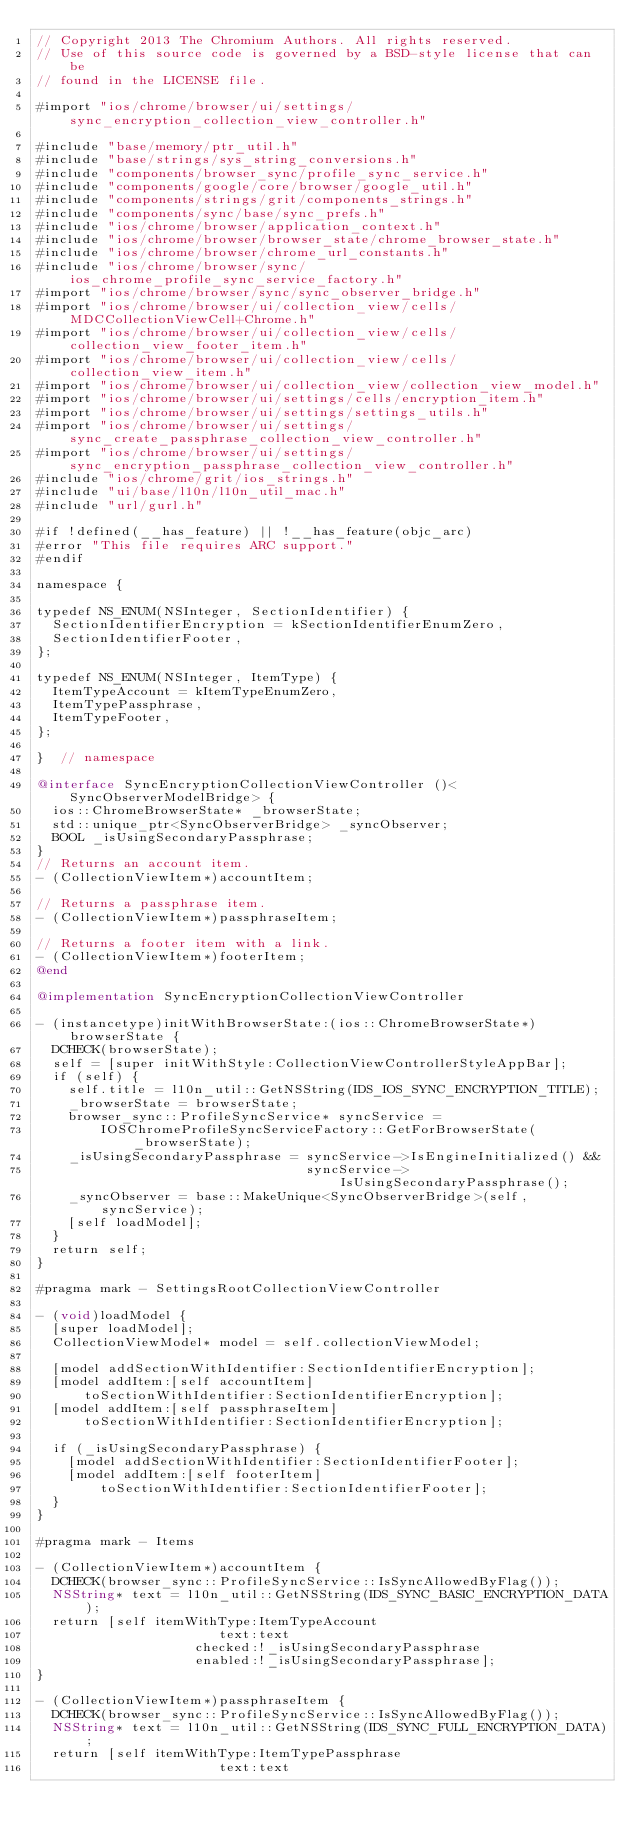Convert code to text. <code><loc_0><loc_0><loc_500><loc_500><_ObjectiveC_>// Copyright 2013 The Chromium Authors. All rights reserved.
// Use of this source code is governed by a BSD-style license that can be
// found in the LICENSE file.

#import "ios/chrome/browser/ui/settings/sync_encryption_collection_view_controller.h"

#include "base/memory/ptr_util.h"
#include "base/strings/sys_string_conversions.h"
#include "components/browser_sync/profile_sync_service.h"
#include "components/google/core/browser/google_util.h"
#include "components/strings/grit/components_strings.h"
#include "components/sync/base/sync_prefs.h"
#include "ios/chrome/browser/application_context.h"
#include "ios/chrome/browser/browser_state/chrome_browser_state.h"
#include "ios/chrome/browser/chrome_url_constants.h"
#include "ios/chrome/browser/sync/ios_chrome_profile_sync_service_factory.h"
#import "ios/chrome/browser/sync/sync_observer_bridge.h"
#import "ios/chrome/browser/ui/collection_view/cells/MDCCollectionViewCell+Chrome.h"
#import "ios/chrome/browser/ui/collection_view/cells/collection_view_footer_item.h"
#import "ios/chrome/browser/ui/collection_view/cells/collection_view_item.h"
#import "ios/chrome/browser/ui/collection_view/collection_view_model.h"
#import "ios/chrome/browser/ui/settings/cells/encryption_item.h"
#import "ios/chrome/browser/ui/settings/settings_utils.h"
#import "ios/chrome/browser/ui/settings/sync_create_passphrase_collection_view_controller.h"
#import "ios/chrome/browser/ui/settings/sync_encryption_passphrase_collection_view_controller.h"
#include "ios/chrome/grit/ios_strings.h"
#include "ui/base/l10n/l10n_util_mac.h"
#include "url/gurl.h"

#if !defined(__has_feature) || !__has_feature(objc_arc)
#error "This file requires ARC support."
#endif

namespace {

typedef NS_ENUM(NSInteger, SectionIdentifier) {
  SectionIdentifierEncryption = kSectionIdentifierEnumZero,
  SectionIdentifierFooter,
};

typedef NS_ENUM(NSInteger, ItemType) {
  ItemTypeAccount = kItemTypeEnumZero,
  ItemTypePassphrase,
  ItemTypeFooter,
};

}  // namespace

@interface SyncEncryptionCollectionViewController ()<SyncObserverModelBridge> {
  ios::ChromeBrowserState* _browserState;
  std::unique_ptr<SyncObserverBridge> _syncObserver;
  BOOL _isUsingSecondaryPassphrase;
}
// Returns an account item.
- (CollectionViewItem*)accountItem;

// Returns a passphrase item.
- (CollectionViewItem*)passphraseItem;

// Returns a footer item with a link.
- (CollectionViewItem*)footerItem;
@end

@implementation SyncEncryptionCollectionViewController

- (instancetype)initWithBrowserState:(ios::ChromeBrowserState*)browserState {
  DCHECK(browserState);
  self = [super initWithStyle:CollectionViewControllerStyleAppBar];
  if (self) {
    self.title = l10n_util::GetNSString(IDS_IOS_SYNC_ENCRYPTION_TITLE);
    _browserState = browserState;
    browser_sync::ProfileSyncService* syncService =
        IOSChromeProfileSyncServiceFactory::GetForBrowserState(_browserState);
    _isUsingSecondaryPassphrase = syncService->IsEngineInitialized() &&
                                  syncService->IsUsingSecondaryPassphrase();
    _syncObserver = base::MakeUnique<SyncObserverBridge>(self, syncService);
    [self loadModel];
  }
  return self;
}

#pragma mark - SettingsRootCollectionViewController

- (void)loadModel {
  [super loadModel];
  CollectionViewModel* model = self.collectionViewModel;

  [model addSectionWithIdentifier:SectionIdentifierEncryption];
  [model addItem:[self accountItem]
      toSectionWithIdentifier:SectionIdentifierEncryption];
  [model addItem:[self passphraseItem]
      toSectionWithIdentifier:SectionIdentifierEncryption];

  if (_isUsingSecondaryPassphrase) {
    [model addSectionWithIdentifier:SectionIdentifierFooter];
    [model addItem:[self footerItem]
        toSectionWithIdentifier:SectionIdentifierFooter];
  }
}

#pragma mark - Items

- (CollectionViewItem*)accountItem {
  DCHECK(browser_sync::ProfileSyncService::IsSyncAllowedByFlag());
  NSString* text = l10n_util::GetNSString(IDS_SYNC_BASIC_ENCRYPTION_DATA);
  return [self itemWithType:ItemTypeAccount
                       text:text
                    checked:!_isUsingSecondaryPassphrase
                    enabled:!_isUsingSecondaryPassphrase];
}

- (CollectionViewItem*)passphraseItem {
  DCHECK(browser_sync::ProfileSyncService::IsSyncAllowedByFlag());
  NSString* text = l10n_util::GetNSString(IDS_SYNC_FULL_ENCRYPTION_DATA);
  return [self itemWithType:ItemTypePassphrase
                       text:text</code> 